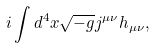<formula> <loc_0><loc_0><loc_500><loc_500>i \int d ^ { 4 } x \sqrt { - g } j ^ { \mu \nu } h _ { \mu \nu } ,</formula> 